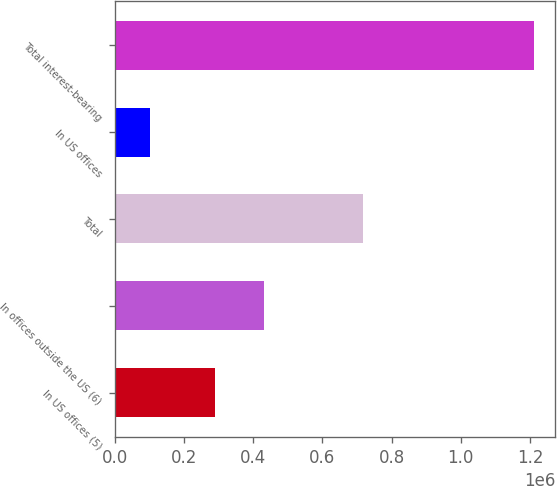<chart> <loc_0><loc_0><loc_500><loc_500><bar_chart><fcel>In US offices (5)<fcel>In offices outside the US (6)<fcel>Total<fcel>In US offices<fcel>Total interest-bearing<nl><fcel>288817<fcel>429608<fcel>718425<fcel>100472<fcel>1.2126e+06<nl></chart> 